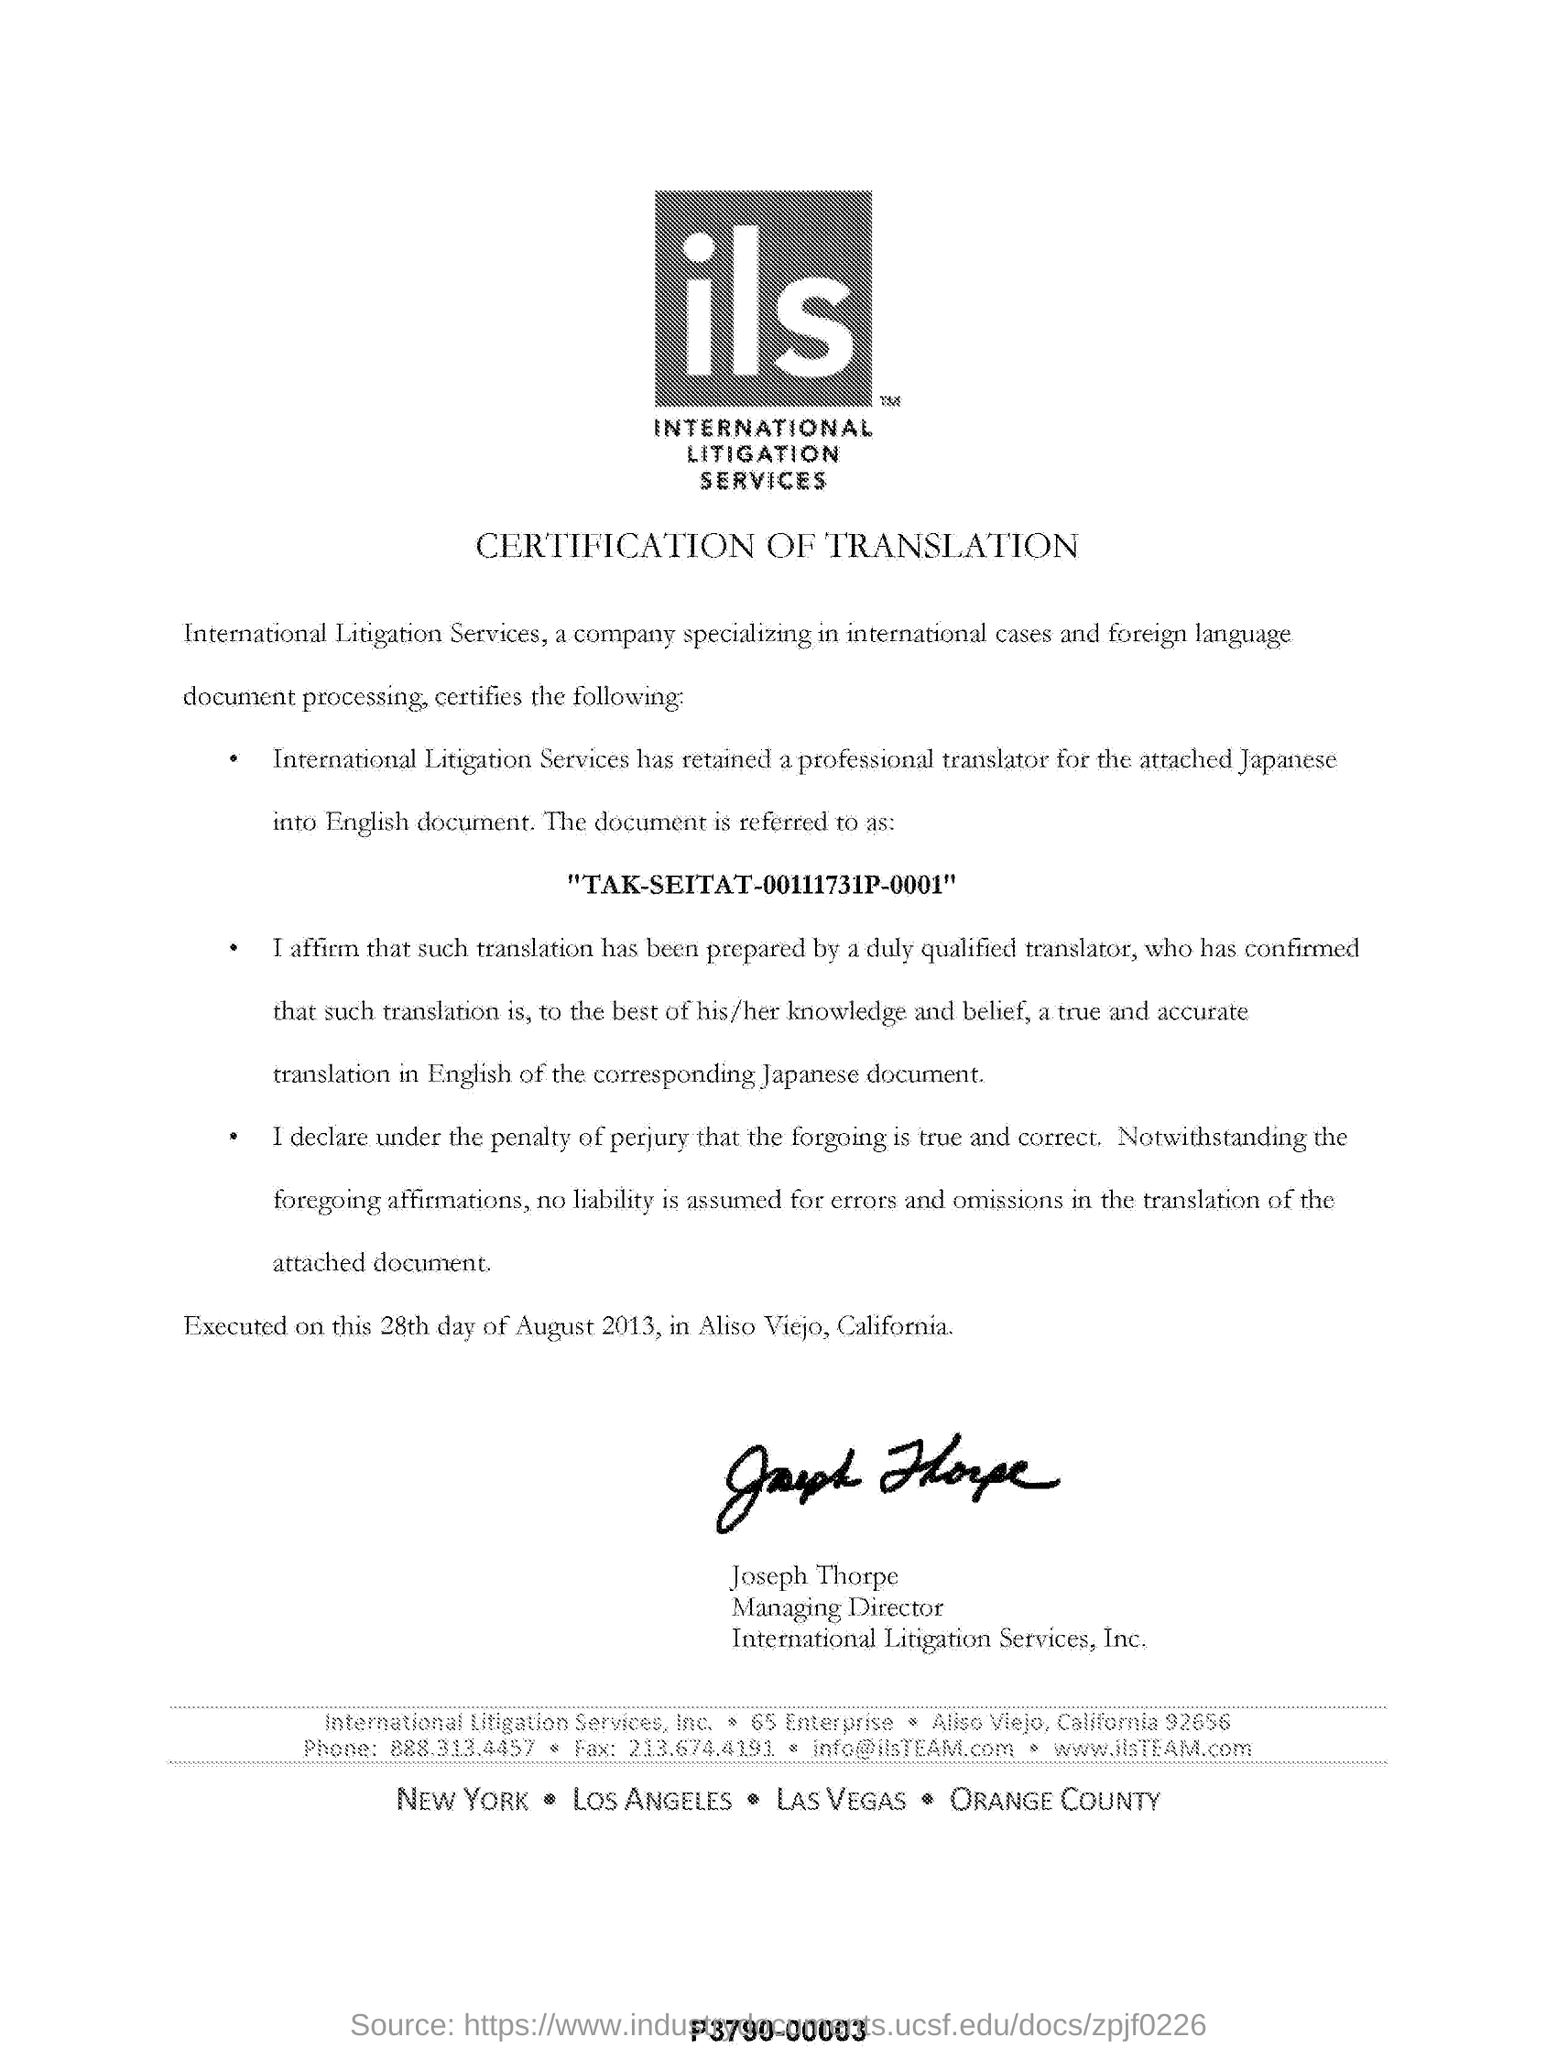Who is the managing director of international litigation services ?
Ensure brevity in your answer.  Joseph Thorpe. When it executed?
Ensure brevity in your answer.  28th day of August 2013. Where was the translation executed at?
Keep it short and to the point. Aliso Viejo, California. 